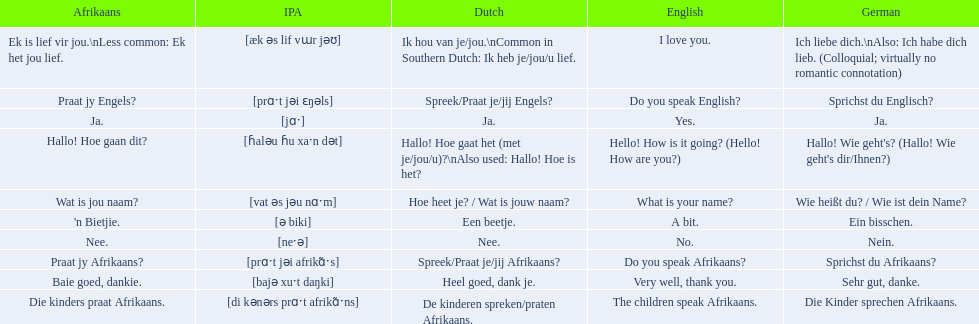How would you say the phrase the children speak afrikaans in afrikaans? Die kinders praat Afrikaans. How would you say the previous phrase in german? Die Kinder sprechen Afrikaans. 